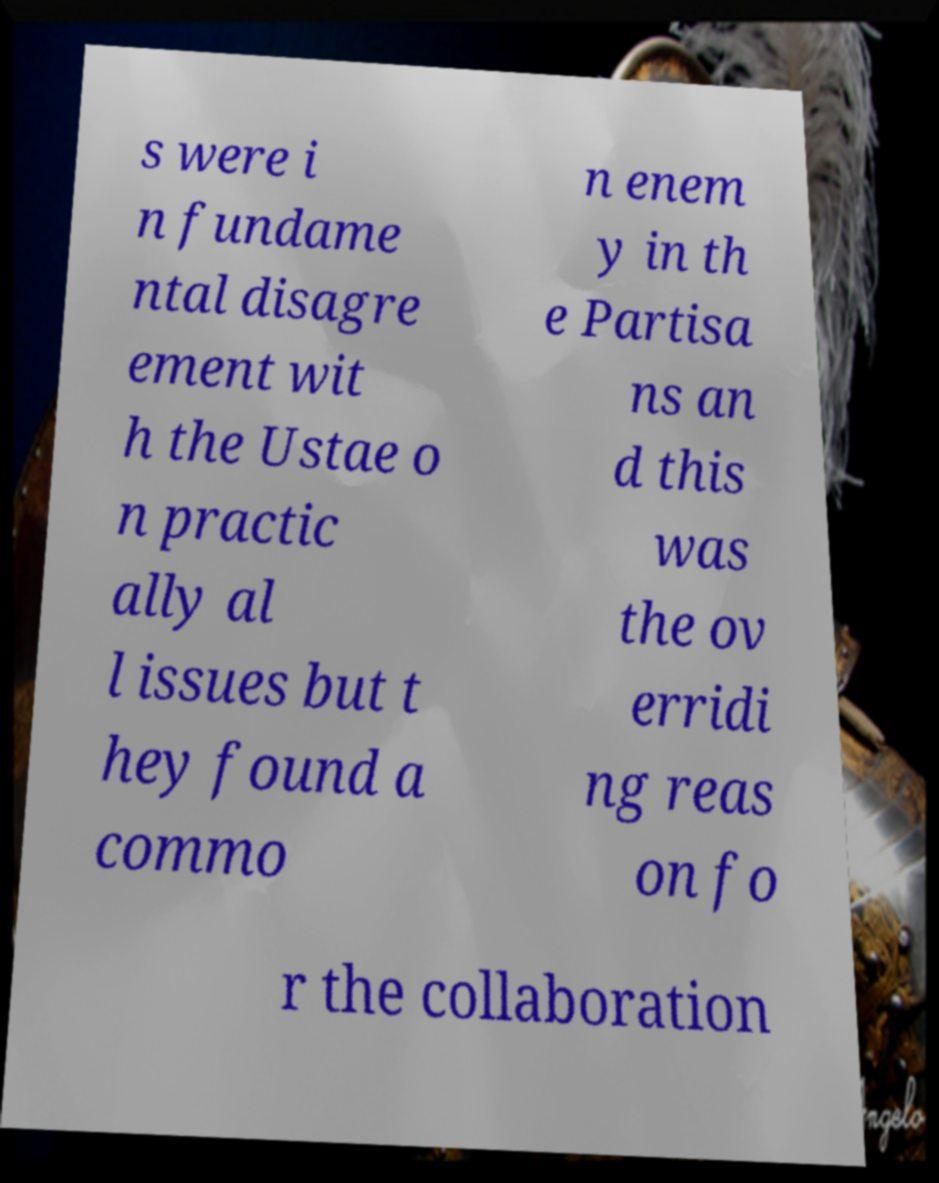Could you extract and type out the text from this image? s were i n fundame ntal disagre ement wit h the Ustae o n practic ally al l issues but t hey found a commo n enem y in th e Partisa ns an d this was the ov erridi ng reas on fo r the collaboration 